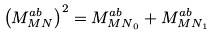Convert formula to latex. <formula><loc_0><loc_0><loc_500><loc_500>\left ( M ^ { a b } _ { M N } \right ) ^ { 2 } = M ^ { a b } _ { { M N } _ { 0 } } + M ^ { a b } _ { { M N } _ { 1 } }</formula> 